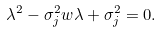Convert formula to latex. <formula><loc_0><loc_0><loc_500><loc_500>\lambda ^ { 2 } - \sigma _ { j } ^ { 2 } w \lambda + \sigma _ { j } ^ { 2 } = 0 .</formula> 